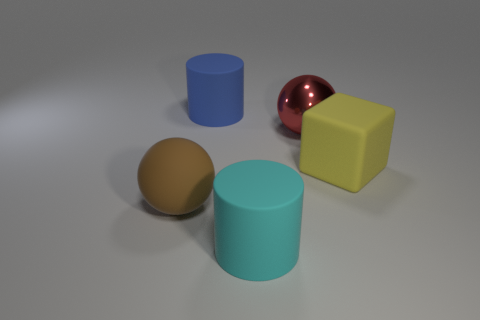Are the big cylinder in front of the red ball and the big block made of the same material?
Your response must be concise. Yes. What is the material of the brown thing that is the same shape as the large red metal object?
Keep it short and to the point. Rubber. Is the number of metal objects less than the number of tiny cyan matte things?
Provide a short and direct response. No. Is the color of the sphere that is on the left side of the cyan cylinder the same as the rubber cube?
Ensure brevity in your answer.  No. The sphere that is made of the same material as the large yellow thing is what color?
Give a very brief answer. Brown. Do the matte ball and the shiny object have the same size?
Provide a short and direct response. Yes. What is the material of the big block?
Provide a short and direct response. Rubber. There is a red thing that is the same size as the brown matte ball; what is it made of?
Your response must be concise. Metal. Are there any red metallic balls of the same size as the red object?
Keep it short and to the point. No. Are there an equal number of red metal balls behind the large yellow rubber thing and big yellow rubber objects in front of the large cyan matte cylinder?
Keep it short and to the point. No. 